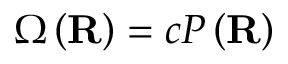<formula> <loc_0><loc_0><loc_500><loc_500>\Omega \left ( R \right ) = c P \left ( R \right )</formula> 